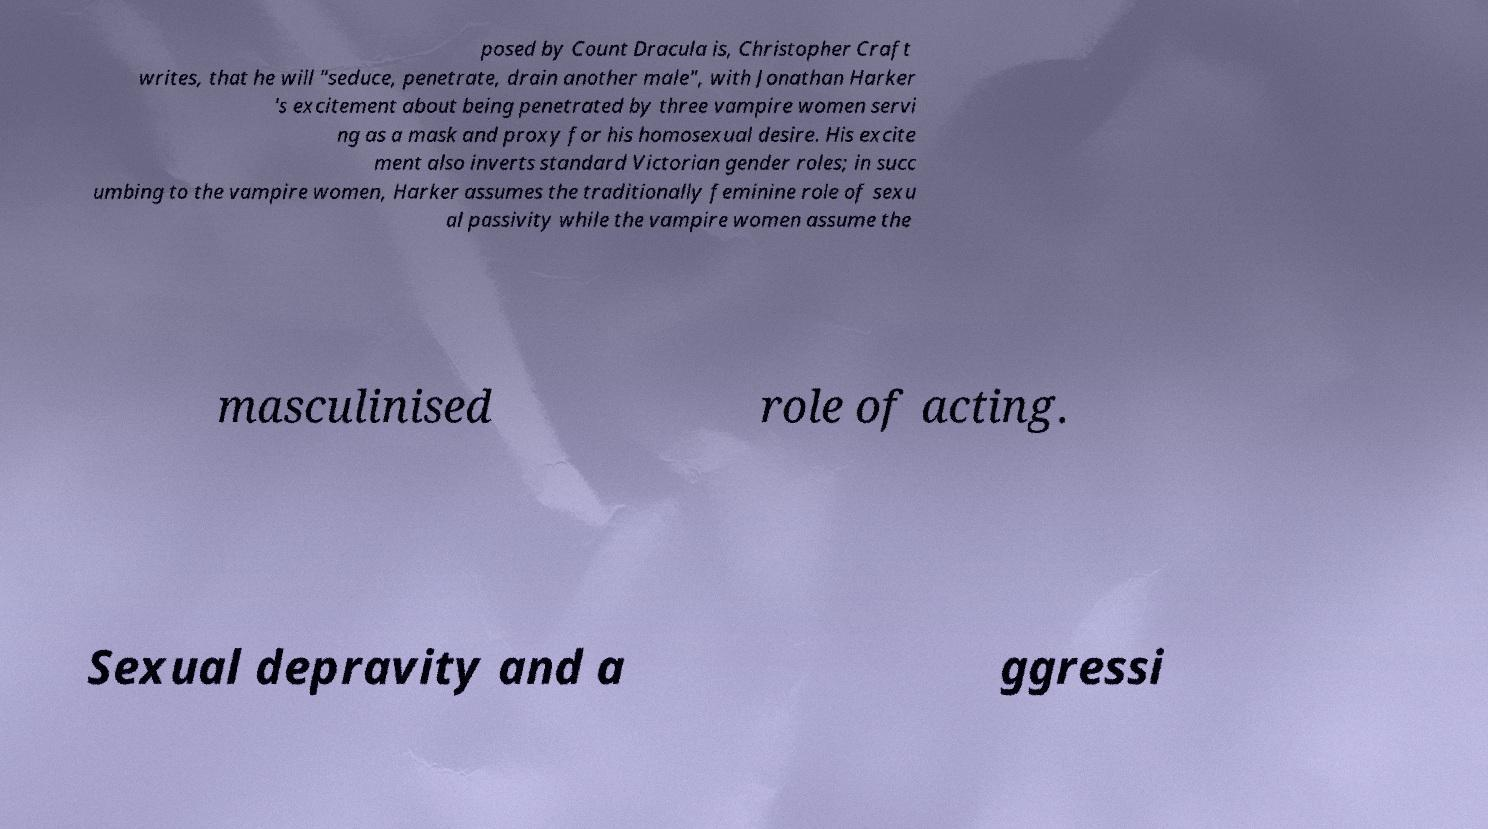I need the written content from this picture converted into text. Can you do that? posed by Count Dracula is, Christopher Craft writes, that he will "seduce, penetrate, drain another male", with Jonathan Harker 's excitement about being penetrated by three vampire women servi ng as a mask and proxy for his homosexual desire. His excite ment also inverts standard Victorian gender roles; in succ umbing to the vampire women, Harker assumes the traditionally feminine role of sexu al passivity while the vampire women assume the masculinised role of acting. Sexual depravity and a ggressi 